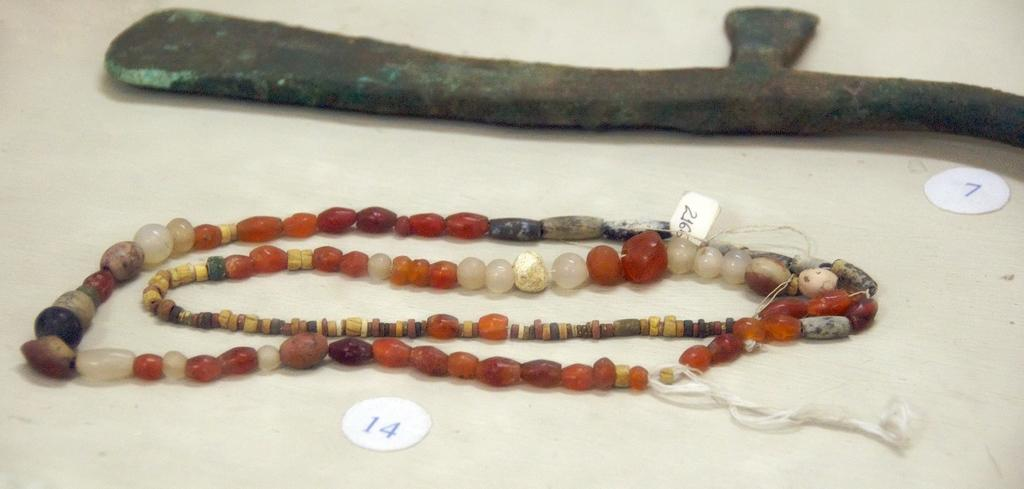What is located in the center of the image? There is a platform in the center of the image. What can be found on the platform? There is an object and an ornament on the platform. Are there any additional details about the objects on the platform? There are tags with numbers visible in the image. Can you tell me how the toad is using its memory to swim in the image? There is no toad present in the image, and therefore no such activity can be observed. 